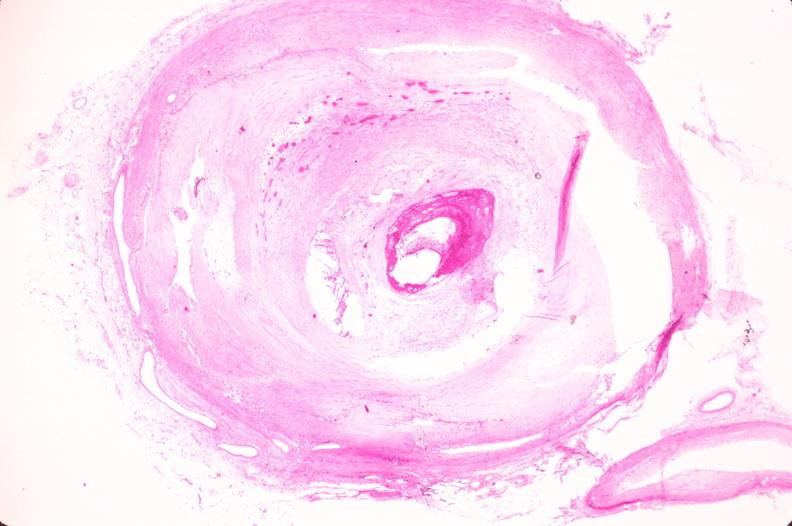s peritoneal fluid present?
Answer the question using a single word or phrase. No 